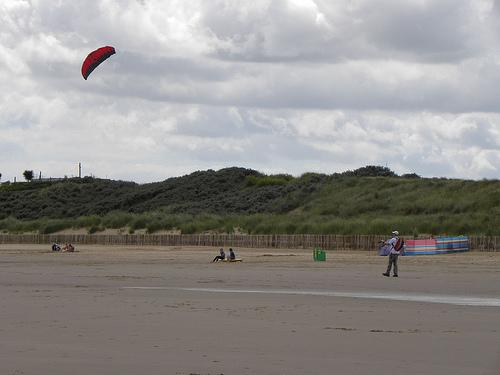Question: where is the photograph taken?
Choices:
A. Camp ground.
B. Hilltop.
C. Beach.
D. Mountain side.
Answer with the letter. Answer: C Question: how is the kite staying in the sky?
Choices:
A. Aerodynamics.
B. String.
C. Wind.
D. Tale.
Answer with the letter. Answer: C Question: who is flying the kite?
Choices:
A. A child.
B. The man with the backpack.
C. A business.
D. A mom.
Answer with the letter. Answer: B Question: what is the weather like?
Choices:
A. Cloudy.
B. Sunny.
C. Rainy.
D. Snowy.
Answer with the letter. Answer: A 